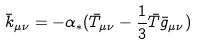Convert formula to latex. <formula><loc_0><loc_0><loc_500><loc_500>\bar { k } _ { \mu \nu } = - \alpha _ { * } ( \bar { T } _ { \mu \nu } - \frac { 1 } { 3 } \bar { T } \bar { g } _ { \mu \nu } )</formula> 